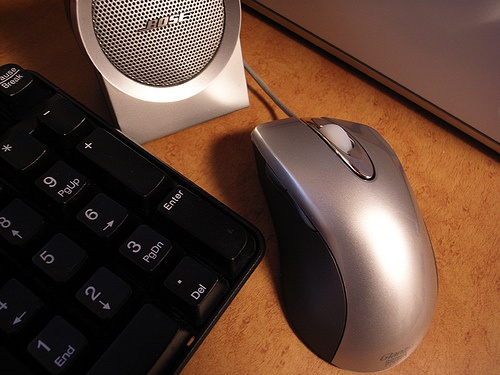Describe the objects in this image and their specific colors. I can see keyboard in maroon, black, gray, and darkgray tones and mouse in maroon, black, gray, and white tones in this image. 